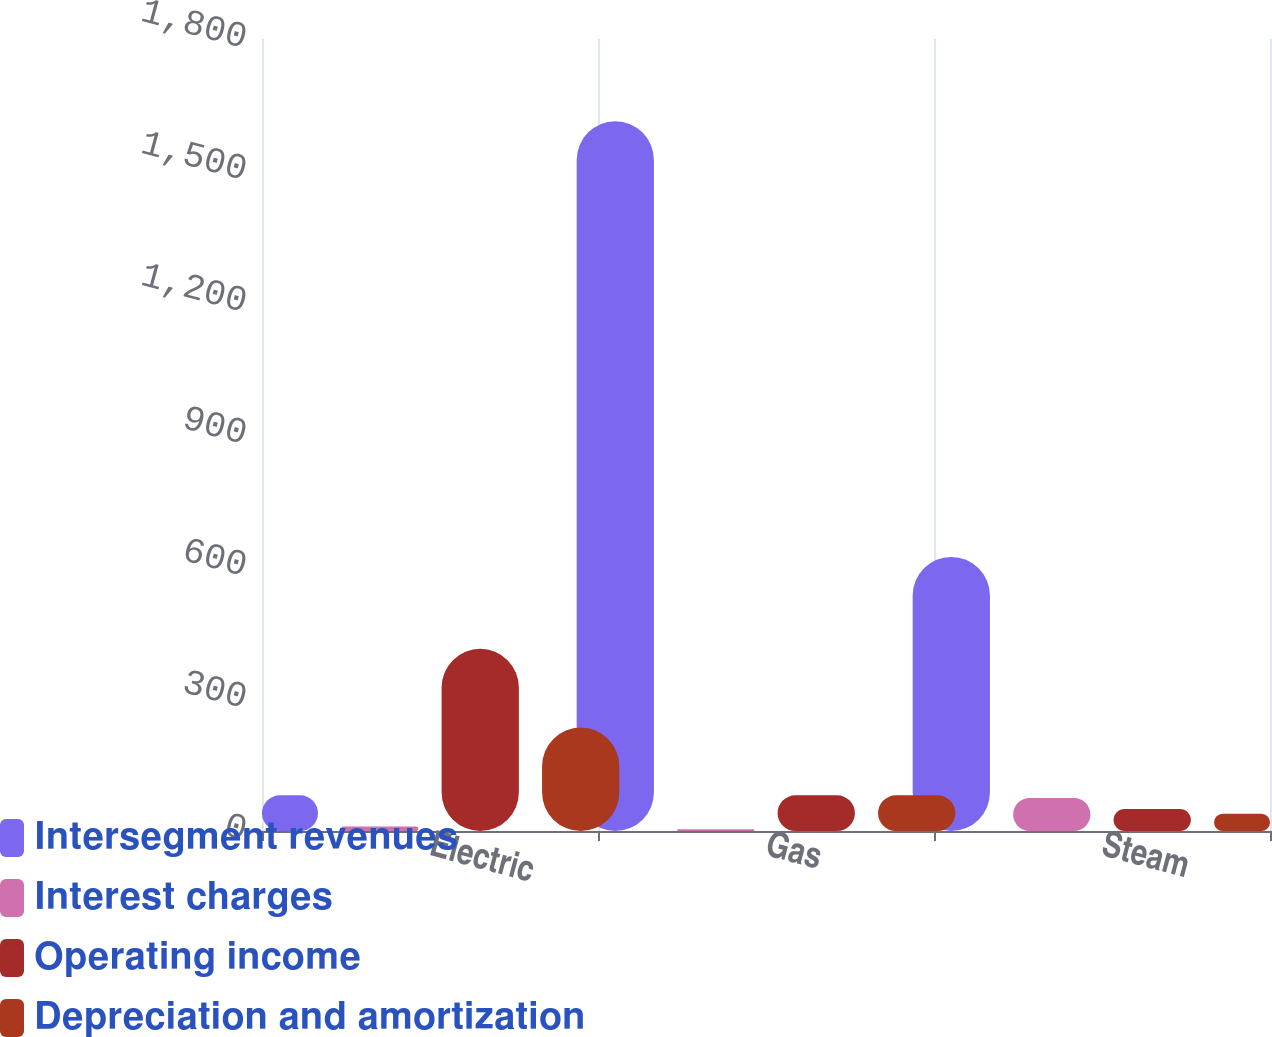<chart> <loc_0><loc_0><loc_500><loc_500><stacked_bar_chart><ecel><fcel>Electric<fcel>Gas<fcel>Steam<nl><fcel>Intersegment revenues<fcel>81<fcel>1613<fcel>623<nl><fcel>Interest charges<fcel>10<fcel>4<fcel>75<nl><fcel>Operating income<fcel>414<fcel>81<fcel>50<nl><fcel>Depreciation and amortization<fcel>235<fcel>81<fcel>39<nl></chart> 